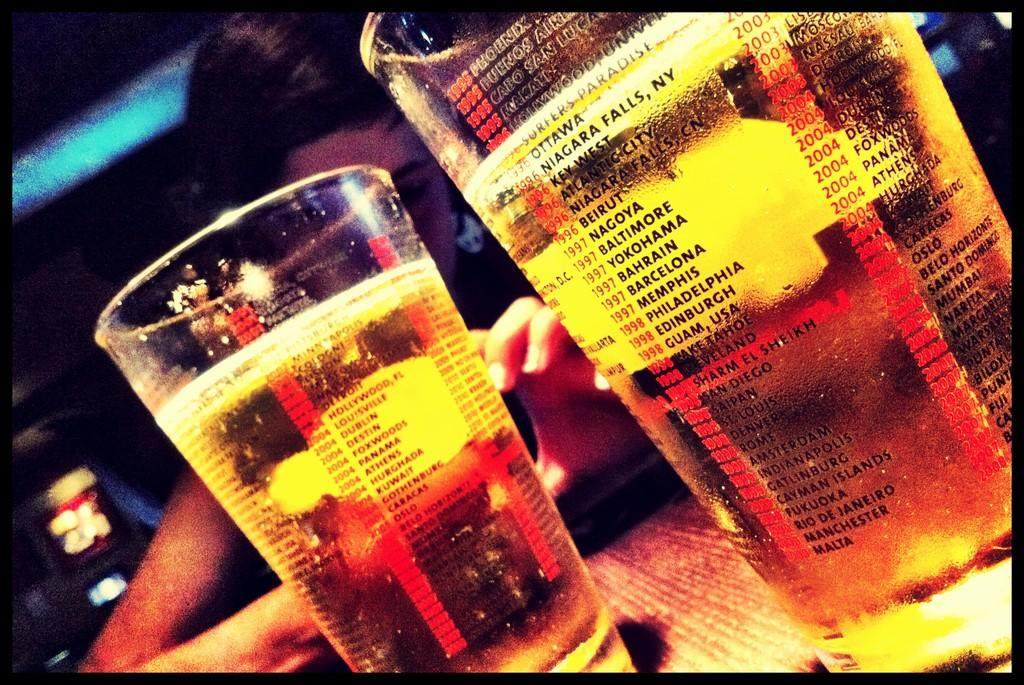<image>
Relay a brief, clear account of the picture shown. Two beer cups with one cup saying "Ottawa" on it. 